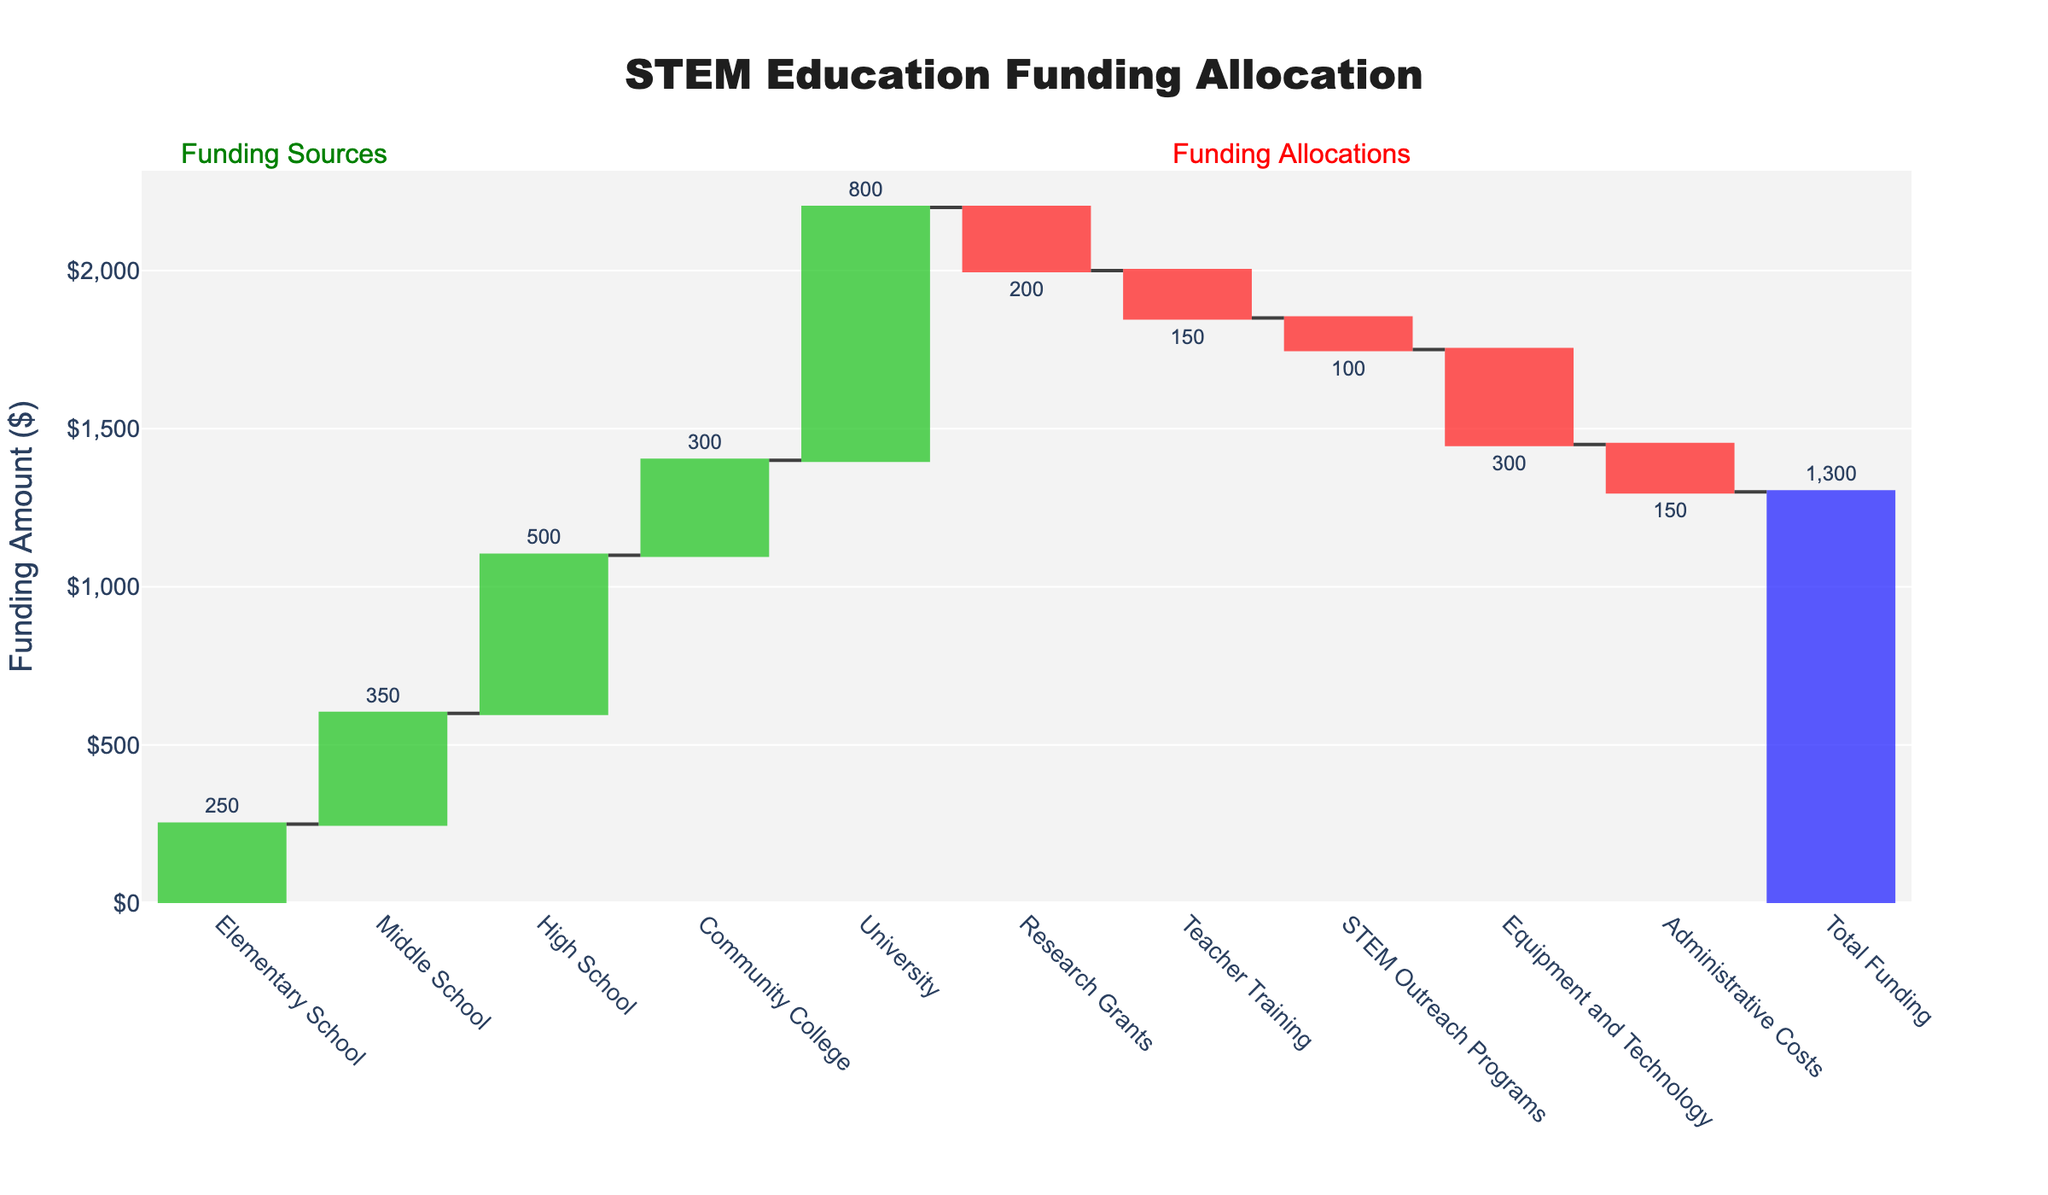What is the title of this chart? The title is usually prominently displayed at the top of the chart. It helps the viewer quickly grasp the main subject of the chart.
Answer: STEM Education Funding Allocation What educational level received the highest funding? Look at the height of the bars representing different educational levels. The tallest bar corresponds to the highest funding.
Answer: University How much funding was allocated to Middle School programs? Identify the bar labeled "Middle School" and read the value displayed on or near the bar.
Answer: 350 What is the total funding amount? Look for the bar at the end of the chart, typically labeled "Total" or "Total Funding," and read its value.
Answer: 1,300 What is the difference in funding between High School and Community College programs? Subtract the funding value for Community College from that for High School. High School: 500, Community College: 300. Calculation: 500 - 300.
Answer: 200 What is the combined funding for Elementary School and Middle School programs? Add the funding values for Elementary School and Middle School. Elementary School: 250, Middle School: 350. Calculation: 250 + 350.
Answer: 600 Which funding allocation has the most significant decrease and what is its value? Look for the largest negative bar (decreasing allocation), which is usually color-coded differently (e.g., red). Identify its label and read the value.
Answer: Equipment and Technology (-300) Compare the funding allocated to Teacher Training and STEM Outreach Programs. Which one is smaller and by how much? Compare the values for both categories. Teacher Training: 150 (negative), STEM Outreach Programs: 100 (negative). Calculate the difference: 150 - 100.
Answer: STEM Outreach Programs by 50 What is the overall positive funding amount before considering any decreases? Sum up all positive funding values (Elementary School, Middle School, High School, Community College, University). Calculation: 250 + 350 + 500 + 300 + 800.
Answer: 2,200 If the funding for Research Grants were increased by 50, what would be the new total funding? Adjust the Research Grants value (currently -200) by adding 50, then recalculate the total funding. Adjusted Research Grants: -150. New total funding: 1,300 - 200 + 50.
Answer: 1,350 